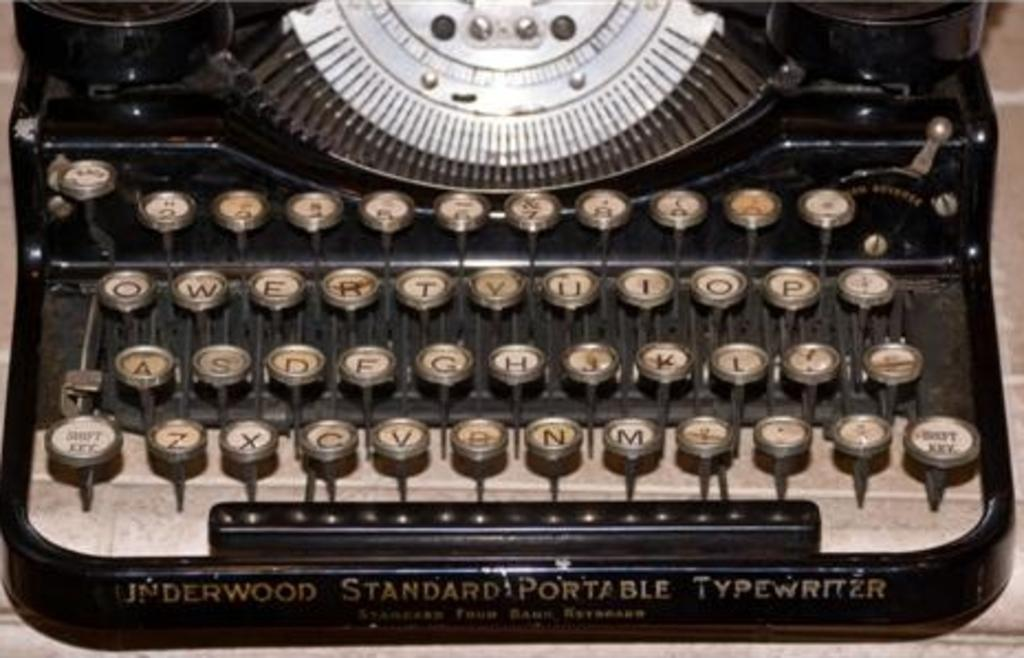<image>
Write a terse but informative summary of the picture. Old typewriter with the words "Inderwood Standard Portable Typewriter" on the bottom. 